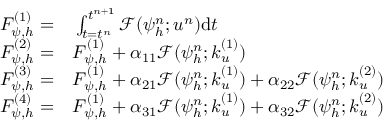<formula> <loc_0><loc_0><loc_500><loc_500>\begin{array} { r l } { F _ { \psi , h } ^ { ( 1 ) } = } & \int _ { t = t ^ { n } } ^ { t ^ { n + 1 } } \mathcal { F } ( { \psi } _ { h } ^ { n } ; u ^ { n } ) d t } \\ { F _ { \psi , h } ^ { ( 2 ) } = } & F _ { \psi , h } ^ { ( 1 ) } + \alpha _ { 1 1 } \mathcal { F } ( { \psi } _ { h } ^ { n } ; k _ { u } ^ { ( 1 ) } ) } \\ { F _ { \psi , h } ^ { ( 3 ) } = } & F _ { \psi , h } ^ { ( 1 ) } + \alpha _ { 2 1 } \mathcal { F } ( { \psi } _ { h } ^ { n } ; k _ { u } ^ { ( 1 ) } ) + \alpha _ { 2 2 } \mathcal { F } ( { \psi } _ { h } ^ { n } ; k _ { u } ^ { ( 2 ) } ) } \\ { F _ { \psi , h } ^ { ( 4 ) } = } & F _ { \psi , h } ^ { ( 1 ) } + \alpha _ { 3 1 } \mathcal { F } ( { \psi } _ { h } ^ { n } ; k _ { u } ^ { ( 1 ) } ) + \alpha _ { 3 2 } \mathcal { F } ( { \psi } _ { h } ^ { n } ; k _ { u } ^ { ( 2 ) } ) } \end{array}</formula> 